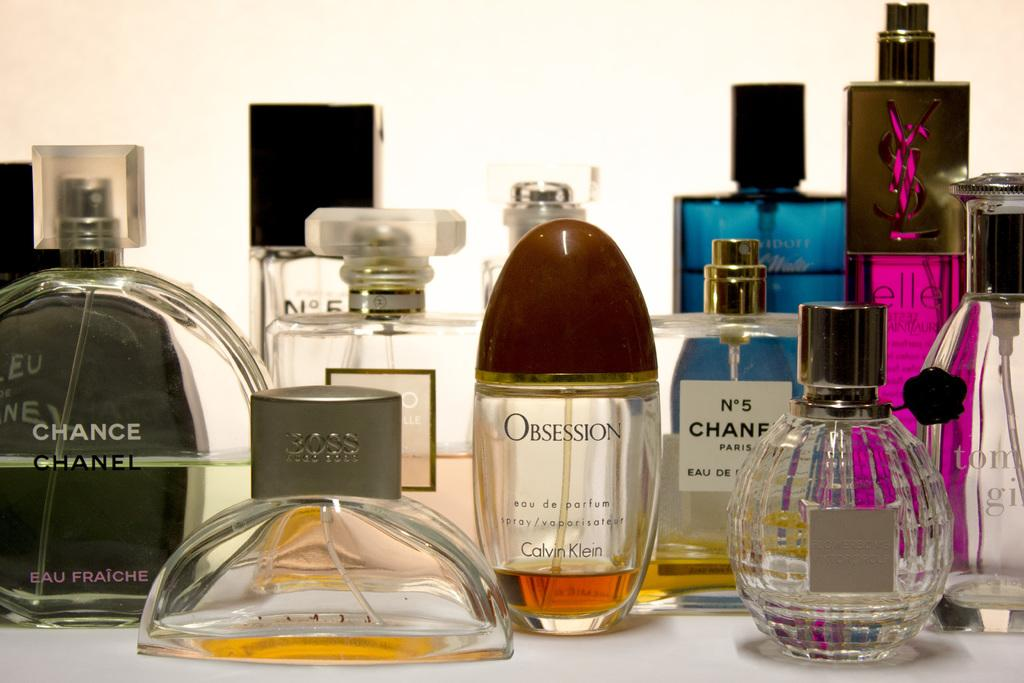Provide a one-sentence caption for the provided image. Twelve perfume bottles from brands such as Calvin Klein, Hugo Boss, Chanel, etc., are displayed, all at different levels of consumption. 